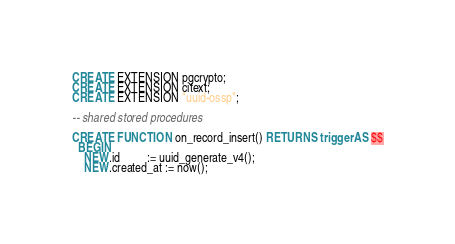<code> <loc_0><loc_0><loc_500><loc_500><_SQL_>CREATE EXTENSION pgcrypto;
CREATE EXTENSION citext;
CREATE EXTENSION "uuid-ossp";

-- shared stored procedures

CREATE FUNCTION on_record_insert() RETURNS trigger AS $$
  BEGIN
    NEW.id         := uuid_generate_v4();
    NEW.created_at := now();</code> 